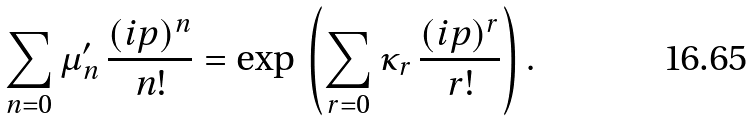<formula> <loc_0><loc_0><loc_500><loc_500>\sum _ { n = 0 } \mu _ { n } ^ { \prime } \, \frac { ( i p ) ^ { n } } { n ! } = \exp \, \left ( { \sum _ { r = 0 } \kappa _ { r } \, \frac { ( i p ) ^ { r } } { r ! } } \right ) .</formula> 